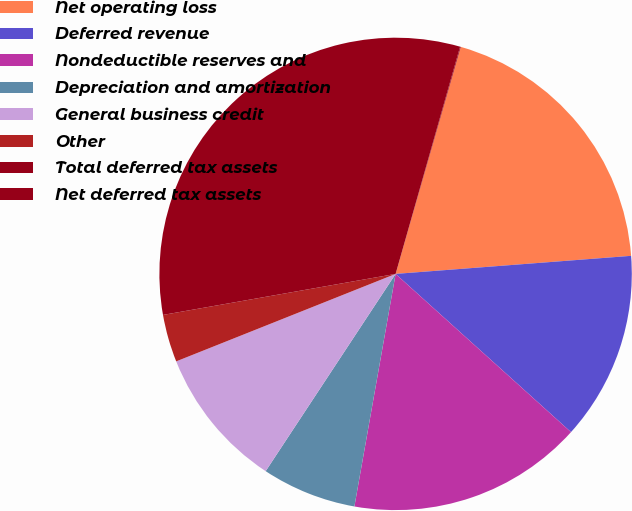Convert chart to OTSL. <chart><loc_0><loc_0><loc_500><loc_500><pie_chart><fcel>Net operating loss<fcel>Deferred revenue<fcel>Nondeductible reserves and<fcel>Depreciation and amortization<fcel>General business credit<fcel>Other<fcel>Total deferred tax assets<fcel>Net deferred tax assets<nl><fcel>19.33%<fcel>12.9%<fcel>16.11%<fcel>6.48%<fcel>9.69%<fcel>3.26%<fcel>32.18%<fcel>0.05%<nl></chart> 